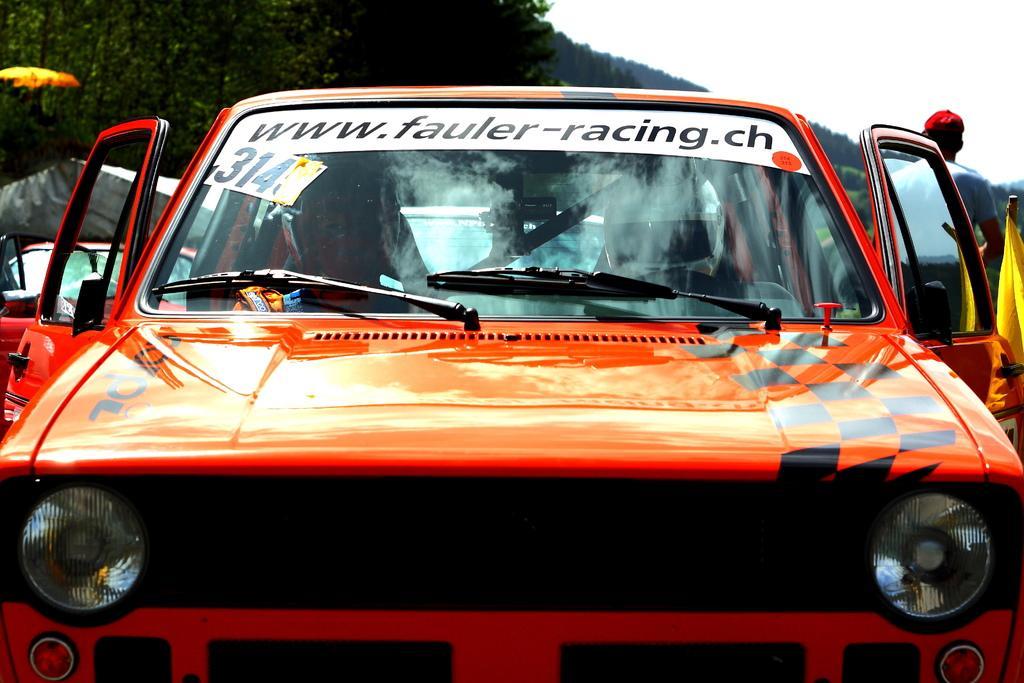In one or two sentences, can you explain what this image depicts? In this image I can see the vehicles. To the right I can see the person standing and wearing the dress and cap. In the background I can see many trees and the sky. 